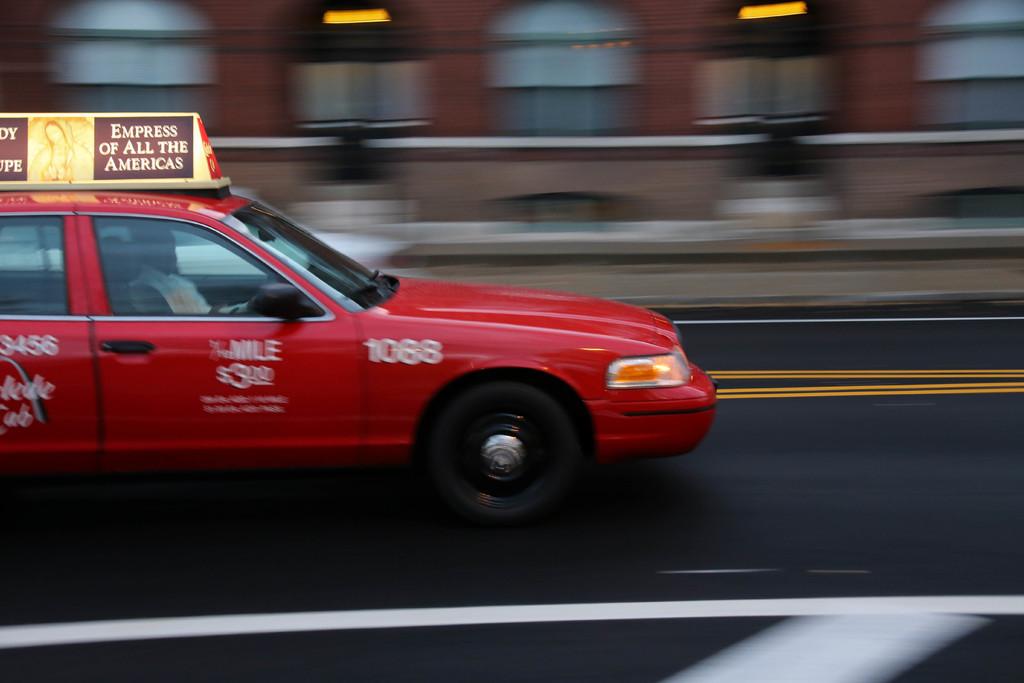What's the taxi's number?
Provide a succinct answer. 1068. What does the sign on top of the taxi say?
Give a very brief answer. Empress of all the americas. 